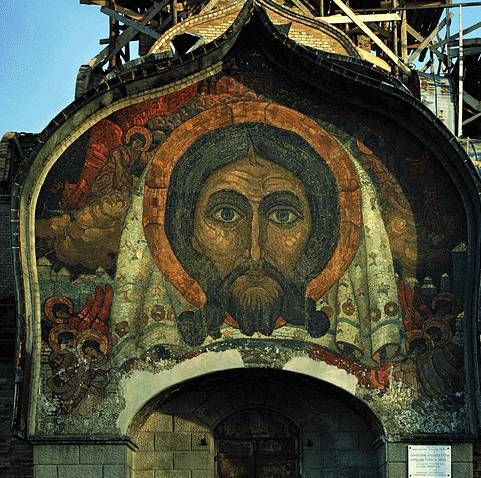What do you notice about the colors and how they contribute to the overall effect of the mosaic? The colors in this mosaic are integral to its visual and symbolic impact. The predominant use of gold creates a divine and ethereal backdrop, a common feature in Byzantine art meant to evoke the presence of the holy. The reds and greens used in Jesus Christ's face add warmth and life, drawing the viewer's attention to the central figure. The various hues harmonize to create a sense of depth and dimension, enhancing the overall grandeur of the piece. The effective use of contrasting colors ensures that each detail stands out, making the mosaic not just a piece of art, but a vibrant narrative of faith. Can you imagine what might have inspired the artist to create this particular depiction of Jesus Christ? The artist who crafted this mosaic might have drawn inspiration from various sources, such as theological texts, earlier religious artworks, and a deep personal faith. Byzantine iconography often followed established conventions for depicting holy figures, so the serene and solemn expression of Jesus Christ would align with traditional representations meant to convey his divine nature and human compassion. The choice of colors and the intricate details may reflect the artist’s interpretation of the light and purity associated with Christ, aiming to inspire awe and reverence among viewers. Additionally, the artist’s intention could have been to create an eternal representation of spiritual truth, transcending the earthly realm and connecting with the divine. 